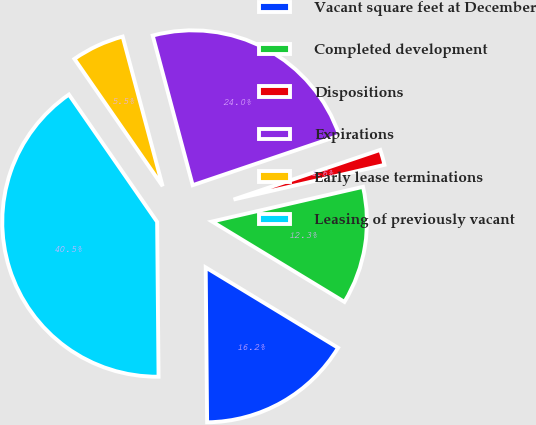<chart> <loc_0><loc_0><loc_500><loc_500><pie_chart><fcel>Vacant square feet at December<fcel>Completed development<fcel>Dispositions<fcel>Expirations<fcel>Early lease terminations<fcel>Leasing of previously vacant<nl><fcel>16.17%<fcel>12.28%<fcel>1.6%<fcel>23.96%<fcel>5.49%<fcel>40.5%<nl></chart> 